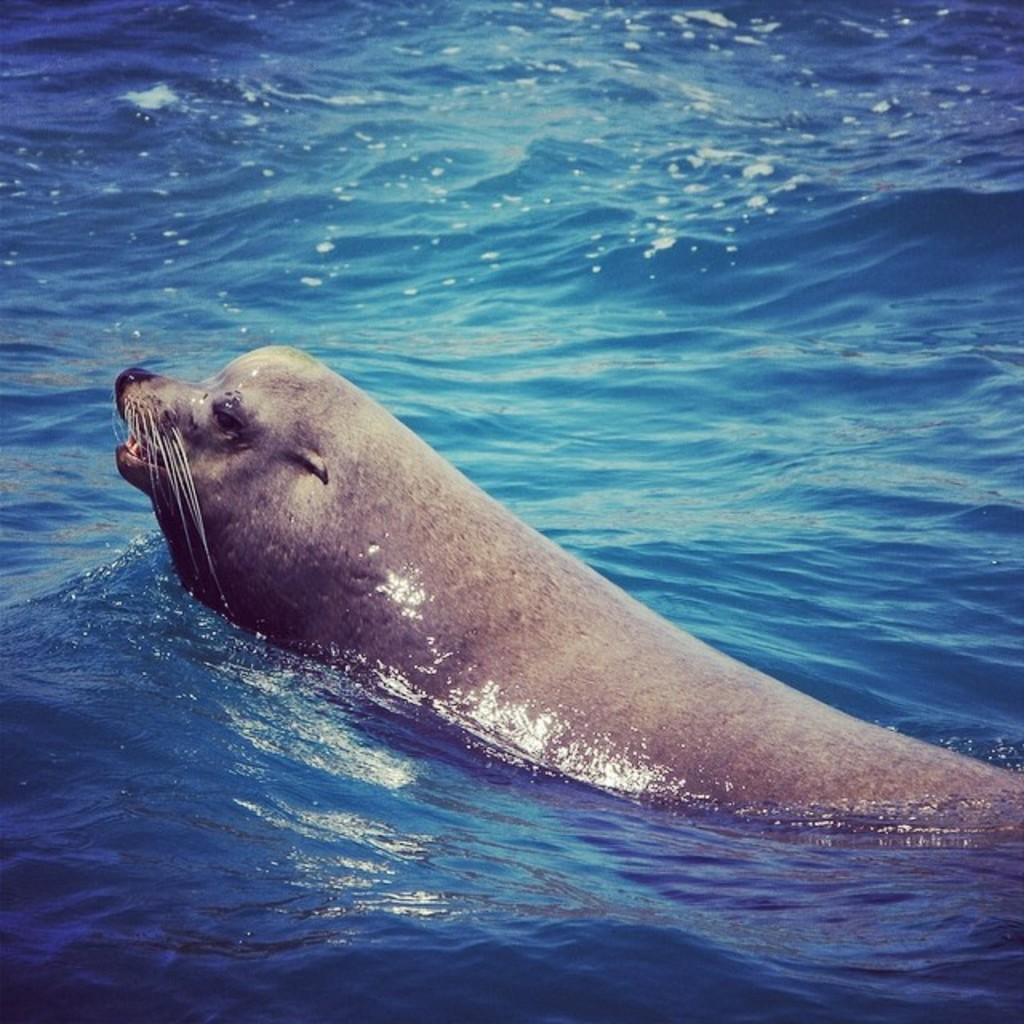What is the primary element visible in the image? There is water in the image. What type of living creature can be seen in the image? There is an animal in the image. What type of footwear is the animal wearing in the image? There is no footwear visible in the image, as animals do not typically wear shoes. What type of zinc can be seen in the image? There is no zinc present in the image. 